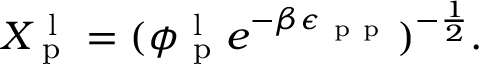<formula> <loc_0><loc_0><loc_500><loc_500>X _ { p } ^ { l } = ( \phi _ { p } ^ { l } e ^ { - \beta \epsilon _ { p p } } ) ^ { - \frac { 1 } { 2 } } .</formula> 